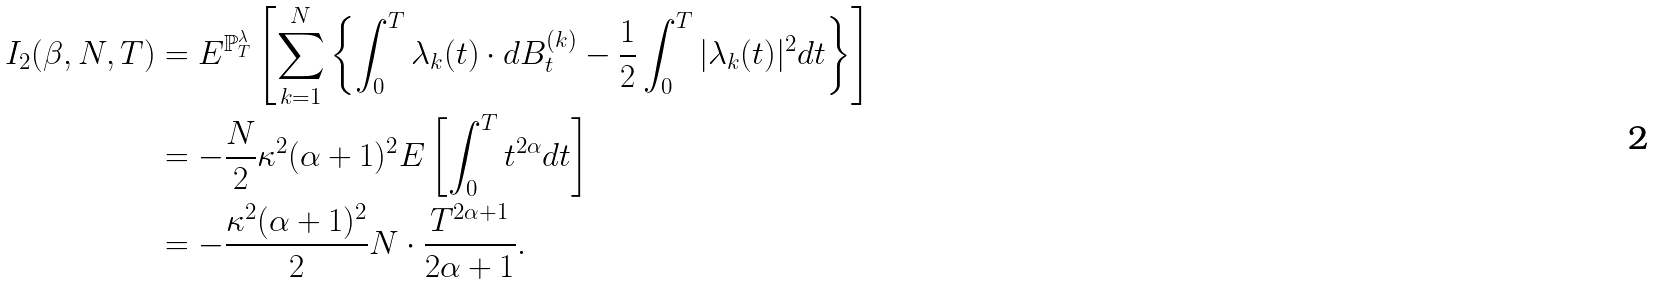<formula> <loc_0><loc_0><loc_500><loc_500>I _ { 2 } ( \beta , N , T ) & = E ^ { \mathbb { P } _ { T } ^ { \lambda } } \left [ \sum _ { k = 1 } ^ { N } \left \{ \int _ { 0 } ^ { T } \lambda _ { k } ( t ) \cdot d B ^ { ( k ) } _ { t } - \frac { 1 } { 2 } \int _ { 0 } ^ { T } | \lambda _ { k } ( t ) | ^ { 2 } d t \right \} \right ] \\ & = - \frac { N } { 2 } \kappa ^ { 2 } ( \alpha + 1 ) ^ { 2 } E \left [ \int _ { 0 } ^ { T } t ^ { 2 \alpha } d t \right ] \\ & = - \frac { \kappa ^ { 2 } ( \alpha + 1 ) ^ { 2 } } { 2 } N \cdot \frac { T ^ { 2 \alpha + 1 } } { 2 \alpha + 1 } .</formula> 